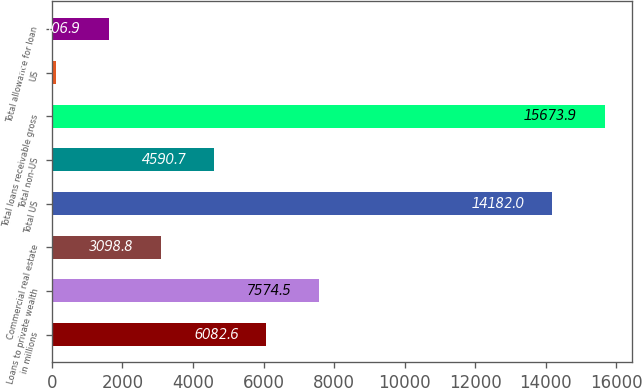<chart> <loc_0><loc_0><loc_500><loc_500><bar_chart><fcel>in millions<fcel>Loans to private wealth<fcel>Commercial real estate<fcel>Total US<fcel>Total non-US<fcel>Total loans receivable gross<fcel>US<fcel>Total allowance for loan<nl><fcel>6082.6<fcel>7574.5<fcel>3098.8<fcel>14182<fcel>4590.7<fcel>15673.9<fcel>115<fcel>1606.9<nl></chart> 